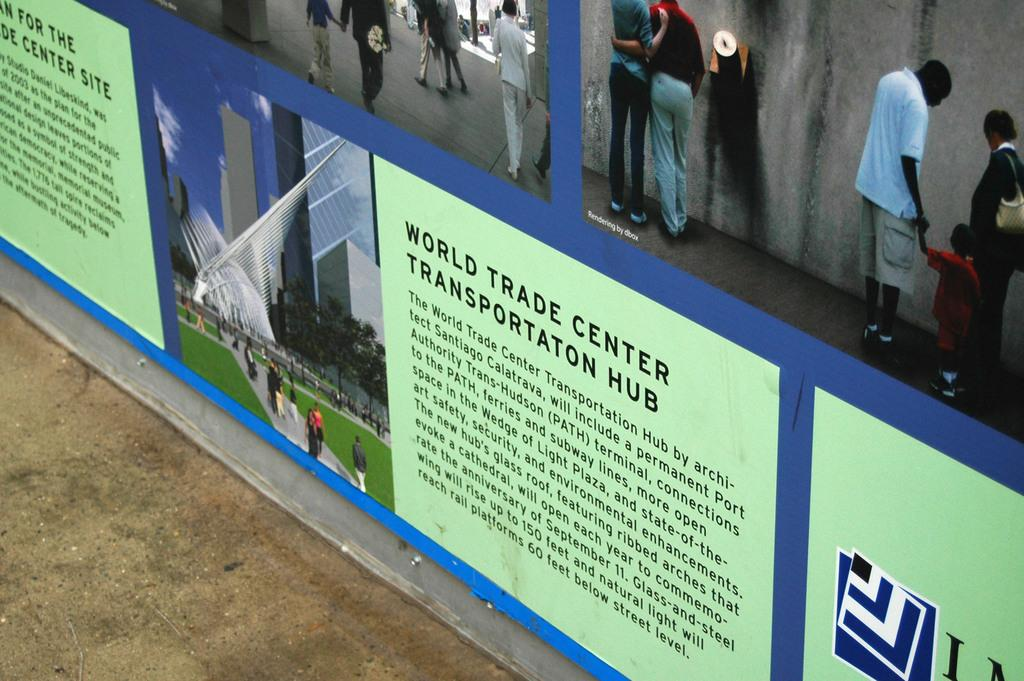What can be seen on the vertical surfaces in the image? There are hoardings on the vertical surfaces in the image. What are the people in the image doing? There is a group of people standing and walking in the image. What is the surface beneath the people's feet? There is a floor in the image. What is the background of the image made up of? There is a wall in the image. What time of day was the image likely taken? The image was likely taken during the day, as there is no indication of darkness or artificial lighting. How many credits can be seen on the hoardings in the image? There are no credits visible on the hoardings in the image. What type of bird is flying in the image? There are no birds present in the image. 